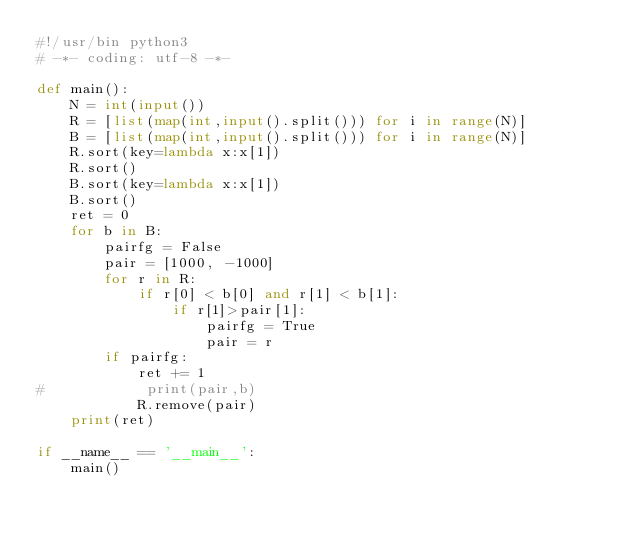<code> <loc_0><loc_0><loc_500><loc_500><_Python_>#!/usr/bin python3
# -*- coding: utf-8 -*-

def main():
    N = int(input())
    R = [list(map(int,input().split())) for i in range(N)]
    B = [list(map(int,input().split())) for i in range(N)]
    R.sort(key=lambda x:x[1])
    R.sort()
    B.sort(key=lambda x:x[1])
    B.sort()
    ret = 0
    for b in B:
        pairfg = False
        pair = [1000, -1000]
        for r in R:
            if r[0] < b[0] and r[1] < b[1]:
                if r[1]>pair[1]:
                    pairfg = True
                    pair = r
        if pairfg:
            ret += 1
#            print(pair,b)
            R.remove(pair)
    print(ret)

if __name__ == '__main__':
    main()</code> 